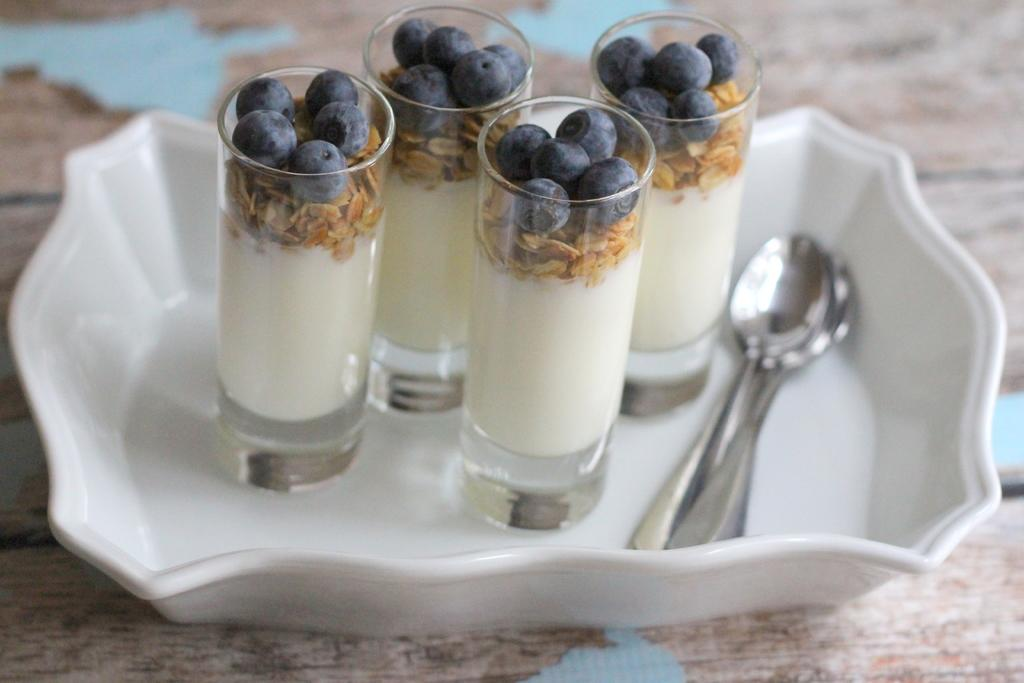What is on the table in the image? There is a tray on the table. What is on the tray? There are glasses and spoons on the tray. What is inside the glasses? The glasses contain drinks with fruits in them. What type of patch is sewn onto the country's flag in the image? There is no patch or flag present in the image; it features a tray with glasses and spoons. 